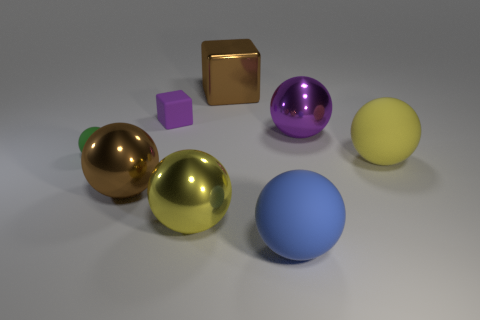Subtract all yellow balls. How many balls are left? 4 Subtract all yellow balls. How many balls are left? 4 Subtract all brown balls. Subtract all red blocks. How many balls are left? 5 Add 1 big green cylinders. How many objects exist? 9 Subtract all blocks. How many objects are left? 6 Add 4 purple cubes. How many purple cubes exist? 5 Subtract 0 gray blocks. How many objects are left? 8 Subtract all yellow rubber things. Subtract all big brown objects. How many objects are left? 5 Add 6 large yellow rubber objects. How many large yellow rubber objects are left? 7 